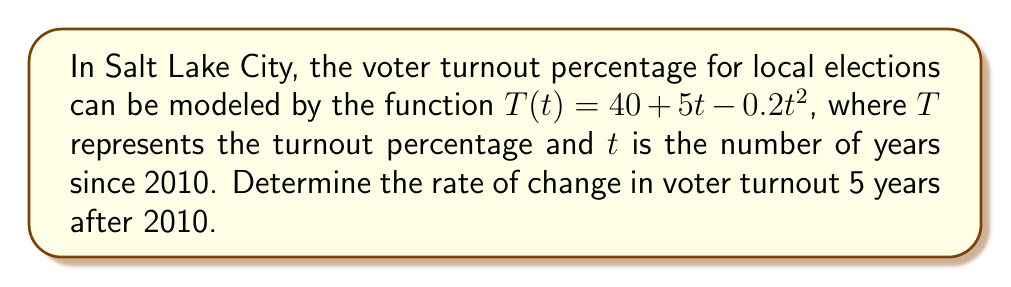Can you solve this math problem? To find the rate of change in voter turnout, we need to calculate the derivative of the given function and evaluate it at $t = 5$.

1. The given function is $T(t) = 40 + 5t - 0.2t^2$

2. To find the derivative, we apply the power rule and constant rule:
   $$\frac{dT}{dt} = 5 - 0.4t$$

3. Now we evaluate the derivative at $t = 5$:
   $$\frac{dT}{dt}\bigg|_{t=5} = 5 - 0.4(5) = 5 - 2 = 3$$

4. The result is positive, indicating that the voter turnout is still increasing 5 years after 2010, but at a decreasing rate due to the negative quadratic term in the original function.

5. The units for this rate of change are percentage points per year, as $T$ is measured in percentages and $t$ in years.
Answer: $3$ percentage points per year 